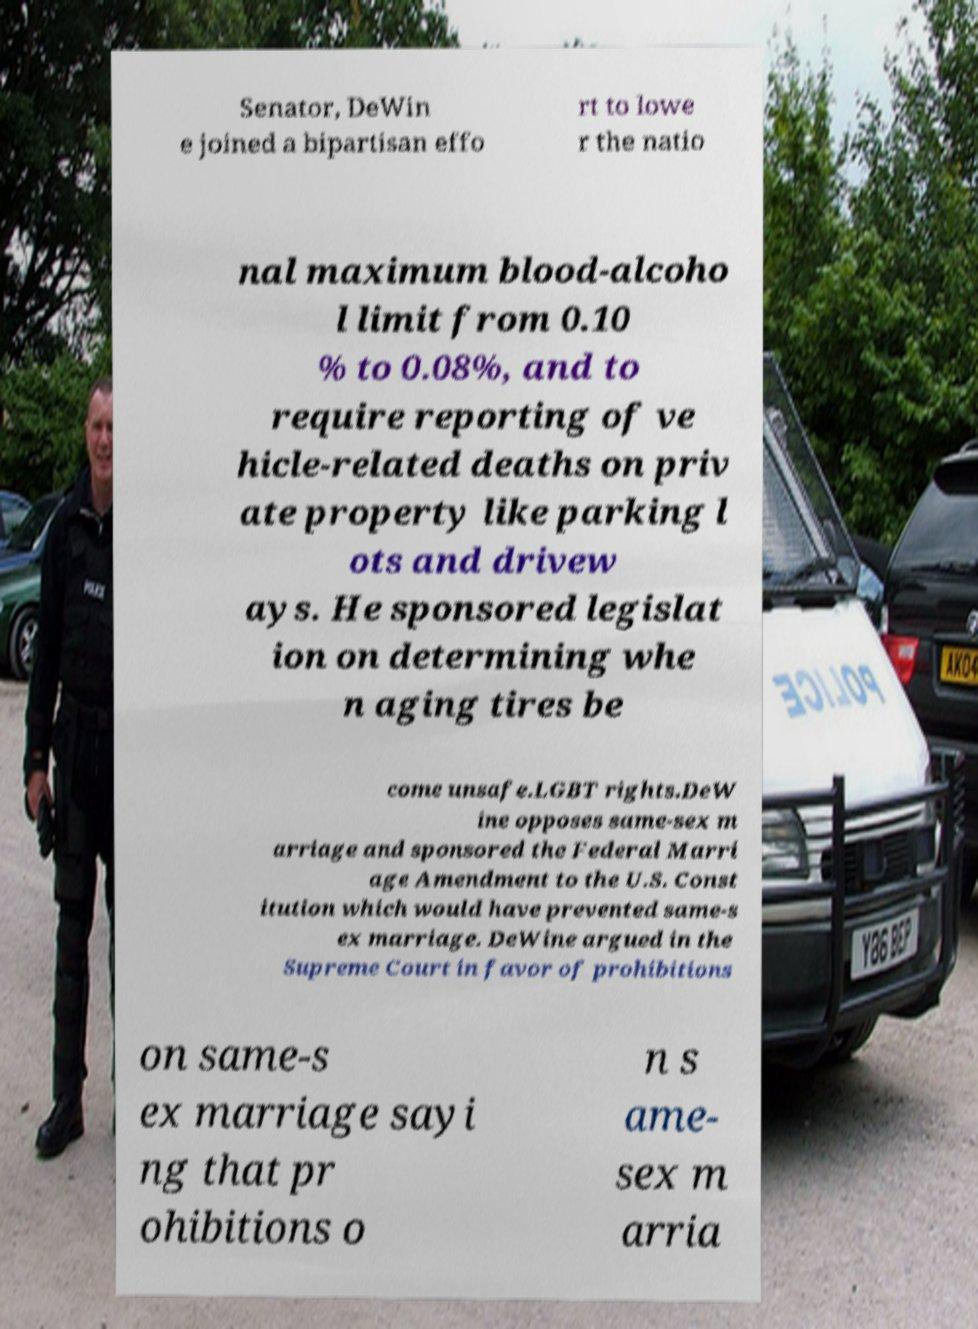Can you accurately transcribe the text from the provided image for me? Senator, DeWin e joined a bipartisan effo rt to lowe r the natio nal maximum blood-alcoho l limit from 0.10 % to 0.08%, and to require reporting of ve hicle-related deaths on priv ate property like parking l ots and drivew ays. He sponsored legislat ion on determining whe n aging tires be come unsafe.LGBT rights.DeW ine opposes same-sex m arriage and sponsored the Federal Marri age Amendment to the U.S. Const itution which would have prevented same-s ex marriage. DeWine argued in the Supreme Court in favor of prohibitions on same-s ex marriage sayi ng that pr ohibitions o n s ame- sex m arria 